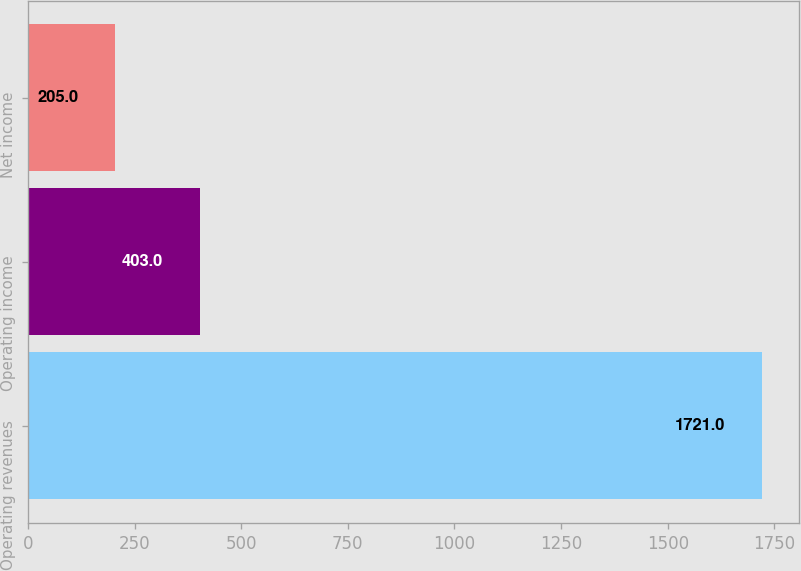Convert chart. <chart><loc_0><loc_0><loc_500><loc_500><bar_chart><fcel>Operating revenues<fcel>Operating income<fcel>Net income<nl><fcel>1721<fcel>403<fcel>205<nl></chart> 